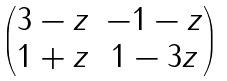<formula> <loc_0><loc_0><loc_500><loc_500>\begin{pmatrix} 3 - z & - 1 - z \\ 1 + z & 1 - 3 z \end{pmatrix}</formula> 